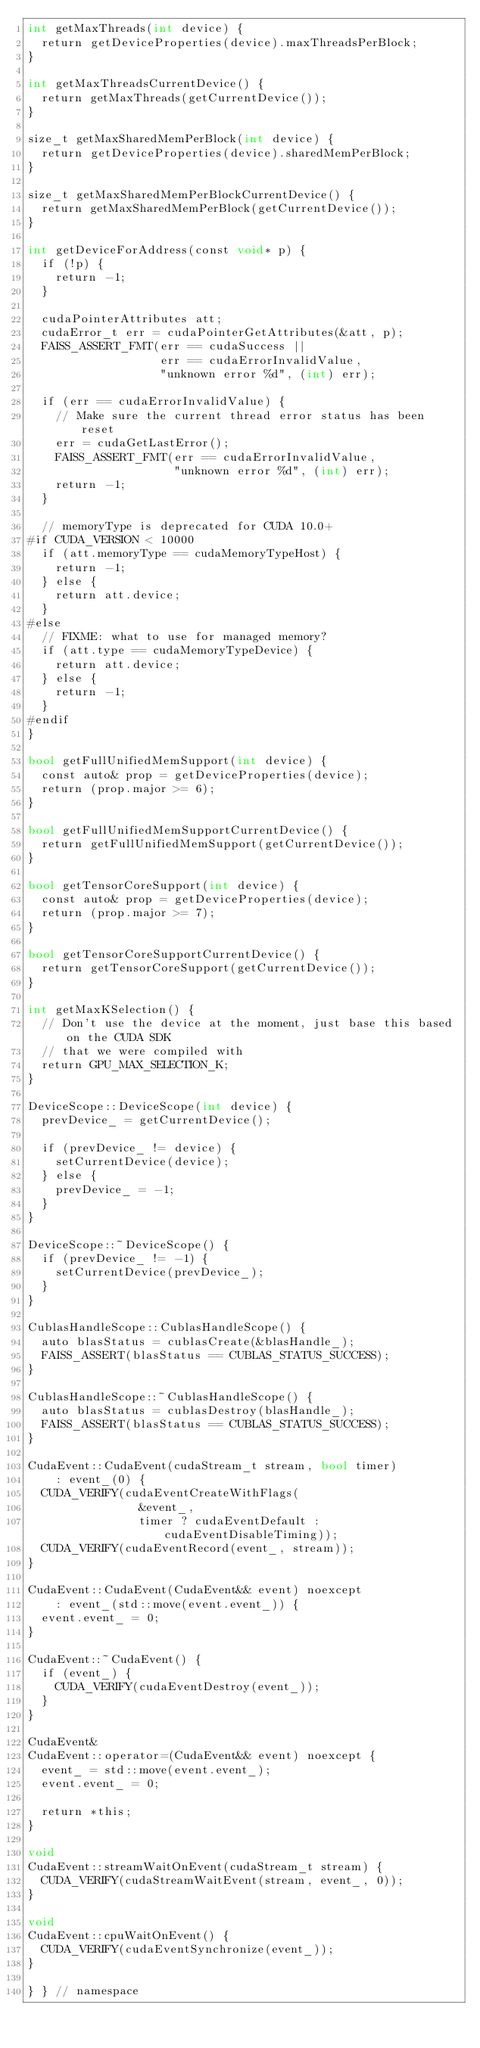Convert code to text. <code><loc_0><loc_0><loc_500><loc_500><_Cuda_>int getMaxThreads(int device) {
  return getDeviceProperties(device).maxThreadsPerBlock;
}

int getMaxThreadsCurrentDevice() {
  return getMaxThreads(getCurrentDevice());
}

size_t getMaxSharedMemPerBlock(int device) {
  return getDeviceProperties(device).sharedMemPerBlock;
}

size_t getMaxSharedMemPerBlockCurrentDevice() {
  return getMaxSharedMemPerBlock(getCurrentDevice());
}

int getDeviceForAddress(const void* p) {
  if (!p) {
    return -1;
  }

  cudaPointerAttributes att;
  cudaError_t err = cudaPointerGetAttributes(&att, p);
  FAISS_ASSERT_FMT(err == cudaSuccess ||
                   err == cudaErrorInvalidValue,
                   "unknown error %d", (int) err);

  if (err == cudaErrorInvalidValue) {
    // Make sure the current thread error status has been reset
    err = cudaGetLastError();
    FAISS_ASSERT_FMT(err == cudaErrorInvalidValue,
                     "unknown error %d", (int) err);
    return -1;
  }

  // memoryType is deprecated for CUDA 10.0+
#if CUDA_VERSION < 10000
  if (att.memoryType == cudaMemoryTypeHost) {
    return -1;
  } else {
    return att.device;
  }
#else
  // FIXME: what to use for managed memory?
  if (att.type == cudaMemoryTypeDevice) {
    return att.device;
  } else {
    return -1;
  }
#endif
}

bool getFullUnifiedMemSupport(int device) {
  const auto& prop = getDeviceProperties(device);
  return (prop.major >= 6);
}

bool getFullUnifiedMemSupportCurrentDevice() {
  return getFullUnifiedMemSupport(getCurrentDevice());
}

bool getTensorCoreSupport(int device) {
  const auto& prop = getDeviceProperties(device);
  return (prop.major >= 7);
}

bool getTensorCoreSupportCurrentDevice() {
  return getTensorCoreSupport(getCurrentDevice());
}

int getMaxKSelection() {
  // Don't use the device at the moment, just base this based on the CUDA SDK
  // that we were compiled with
  return GPU_MAX_SELECTION_K;
}

DeviceScope::DeviceScope(int device) {
  prevDevice_ = getCurrentDevice();

  if (prevDevice_ != device) {
    setCurrentDevice(device);
  } else {
    prevDevice_ = -1;
  }
}

DeviceScope::~DeviceScope() {
  if (prevDevice_ != -1) {
    setCurrentDevice(prevDevice_);
  }
}

CublasHandleScope::CublasHandleScope() {
  auto blasStatus = cublasCreate(&blasHandle_);
  FAISS_ASSERT(blasStatus == CUBLAS_STATUS_SUCCESS);
}

CublasHandleScope::~CublasHandleScope() {
  auto blasStatus = cublasDestroy(blasHandle_);
  FAISS_ASSERT(blasStatus == CUBLAS_STATUS_SUCCESS);
}

CudaEvent::CudaEvent(cudaStream_t stream, bool timer)
    : event_(0) {
  CUDA_VERIFY(cudaEventCreateWithFlags(
                &event_,
                timer ? cudaEventDefault : cudaEventDisableTiming));
  CUDA_VERIFY(cudaEventRecord(event_, stream));
}

CudaEvent::CudaEvent(CudaEvent&& event) noexcept
    : event_(std::move(event.event_)) {
  event.event_ = 0;
}

CudaEvent::~CudaEvent() {
  if (event_) {
    CUDA_VERIFY(cudaEventDestroy(event_));
  }
}

CudaEvent&
CudaEvent::operator=(CudaEvent&& event) noexcept {
  event_ = std::move(event.event_);
  event.event_ = 0;

  return *this;
}

void
CudaEvent::streamWaitOnEvent(cudaStream_t stream) {
  CUDA_VERIFY(cudaStreamWaitEvent(stream, event_, 0));
}

void
CudaEvent::cpuWaitOnEvent() {
  CUDA_VERIFY(cudaEventSynchronize(event_));
}

} } // namespace
</code> 